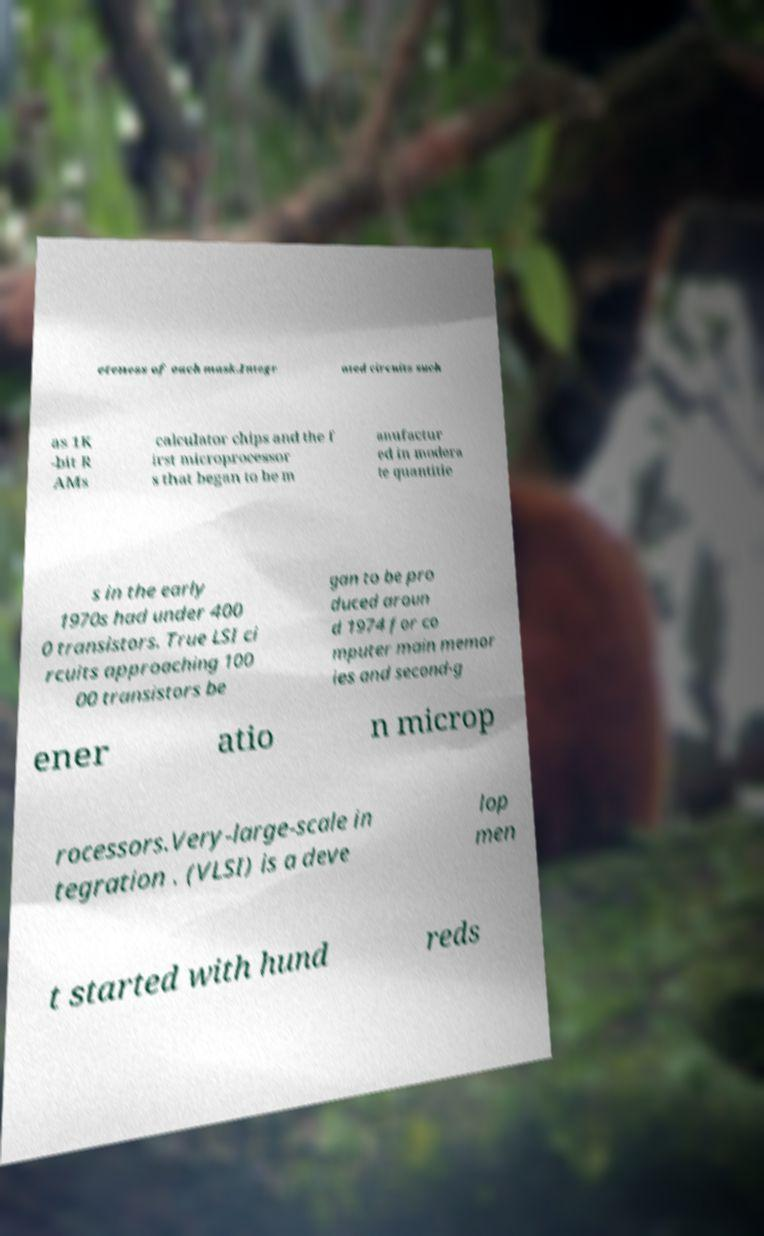Could you extract and type out the text from this image? eteness of each mask.Integr ated circuits such as 1K -bit R AMs calculator chips and the f irst microprocessor s that began to be m anufactur ed in modera te quantitie s in the early 1970s had under 400 0 transistors. True LSI ci rcuits approaching 100 00 transistors be gan to be pro duced aroun d 1974 for co mputer main memor ies and second-g ener atio n microp rocessors.Very-large-scale in tegration . (VLSI) is a deve lop men t started with hund reds 